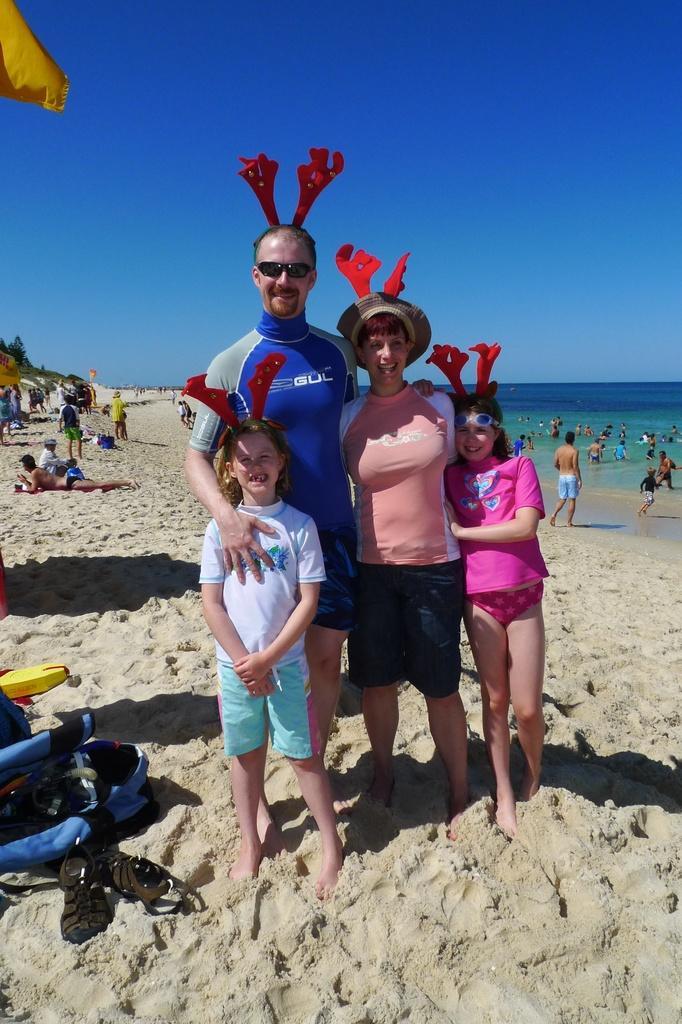In one or two sentences, can you explain what this image depicts? As we can see in the image there are few people here and there, sand, water and a sky. 